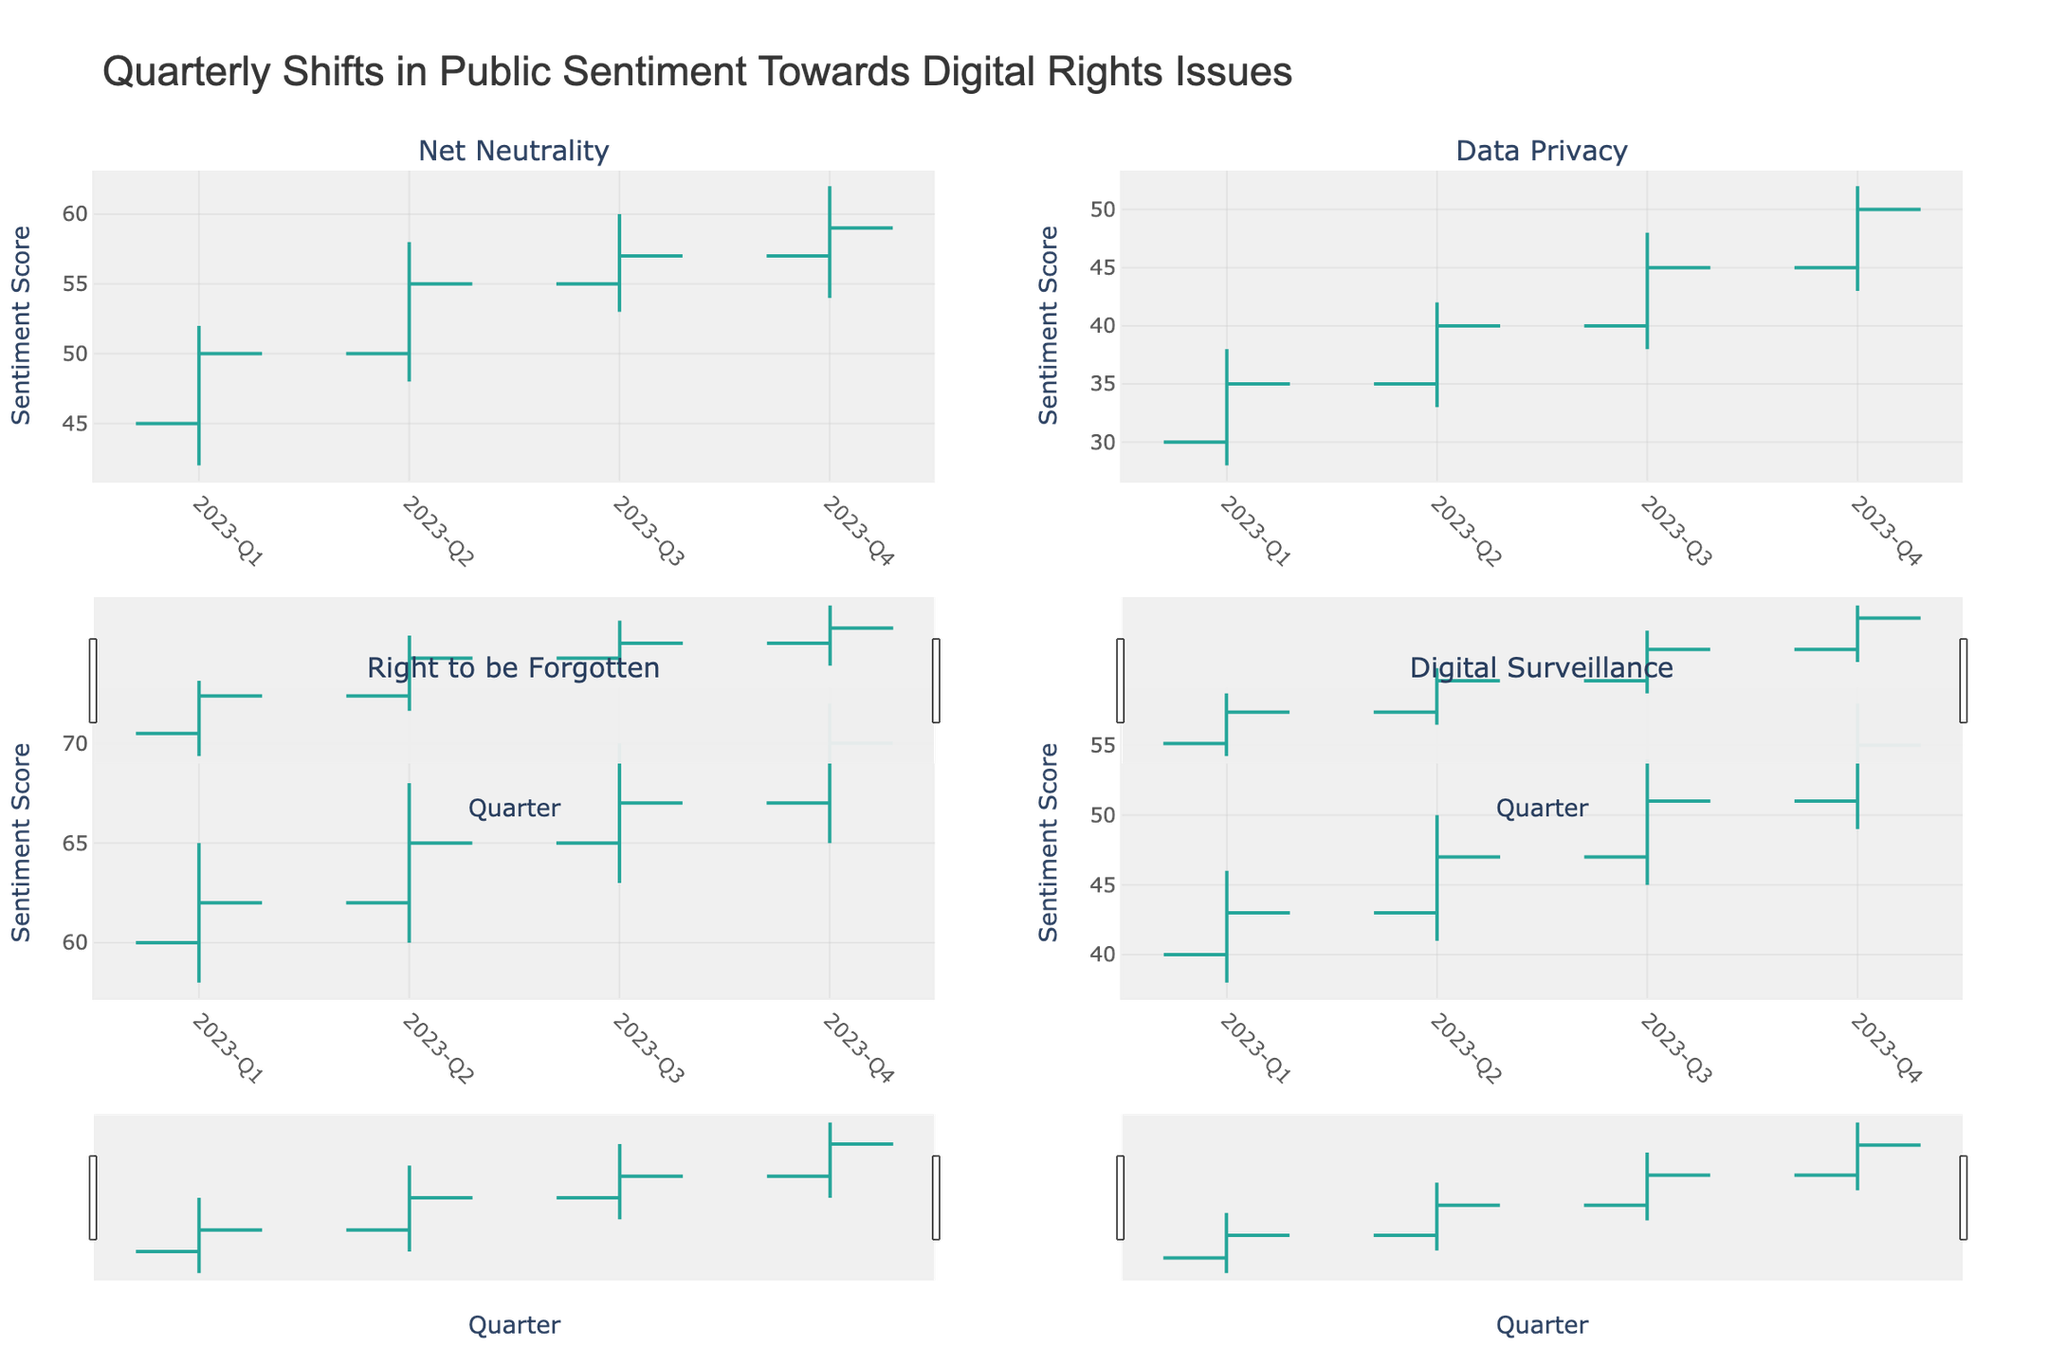What is the title of the chart? The title is located at the top center of the figure and provides a summary of what the chart represents.
Answer: Quarterly Shifts in Public Sentiment Towards Digital Rights Issues How many digital rights issues are being tracked in this chart? The subplot titles indicate each tracked issue, visible in each of the four quadrants.
Answer: Four Which quarter shows the highest sentiment for the issue "Net Neutrality"? The "High" value for each quarter needs to be compared for Net Neutrality. Q4 has the highest sentiment score with 62.
Answer: Q4 What is the range of sentiment scores for "Data Privacy" in Q3? The range is the difference between the High and Low values. For Q3, the values are 48 and 38. The range is 48 - 38 = 10.
Answer: 10 Between which quarters does "Right to be Forgotten" show the most significant increase in closing sentiment? By comparing the close values, Q3 to Q4 shows the most significant increase from 67 to 70. The increase is 70 - 67 = 3.
Answer: Q3 to Q4 What is the difference between the opening sentiment of "Digital Surveillance" in Q1 and its closing sentiment in Q4? The opening sentiment in Q1 is 40, and the closing sentiment in Q4 is 55. The difference is 55 - 40 = 15.
Answer: 15 Among the four issues, which one has had the most stable sentiment trend (least variation in High and Low values across all quarters)? Calculate the range of High and Low values for each issue and find the one with the least variation. "Net Neutrality" ranges from 62-42, "Data Privacy" from 52-28, "Right to be Forgotten" from 72-58, and "Digital Surveillance" from 58-38. "Right to be Forgotten" has the least variation of 72 - 58 = 14.
Answer: Right to be Forgotten What is the trend of sentiment scores for "Digital Surveillance" over the four quarters? Analyze the Close values for each quarter to observe the trend. They are 43, 47, 51, and 55. The trend is a steady increase.
Answer: Increasing What is the average closing sentiment for "Right to be Forgotten" over the four quarters? Sum the Close values for all quarters and divide by the number of quarters. The Close values are 62, 65, 67, and 70. The sum is 62 + 65 + 67 + 70 = 264. The average is 264 / 4 = 66.
Answer: 66 